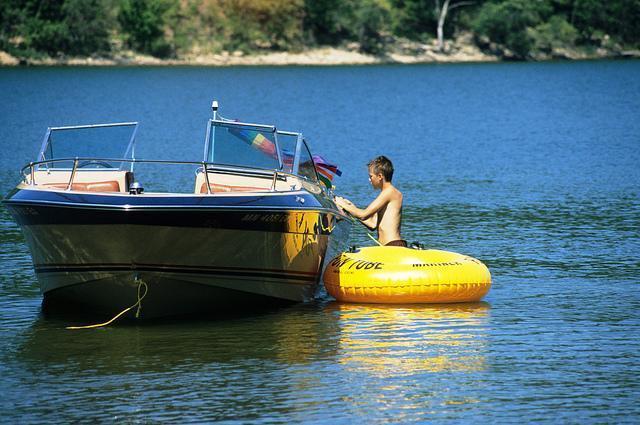How many boats are there?
Give a very brief answer. 2. How many black remotes are on the table?
Give a very brief answer. 0. 